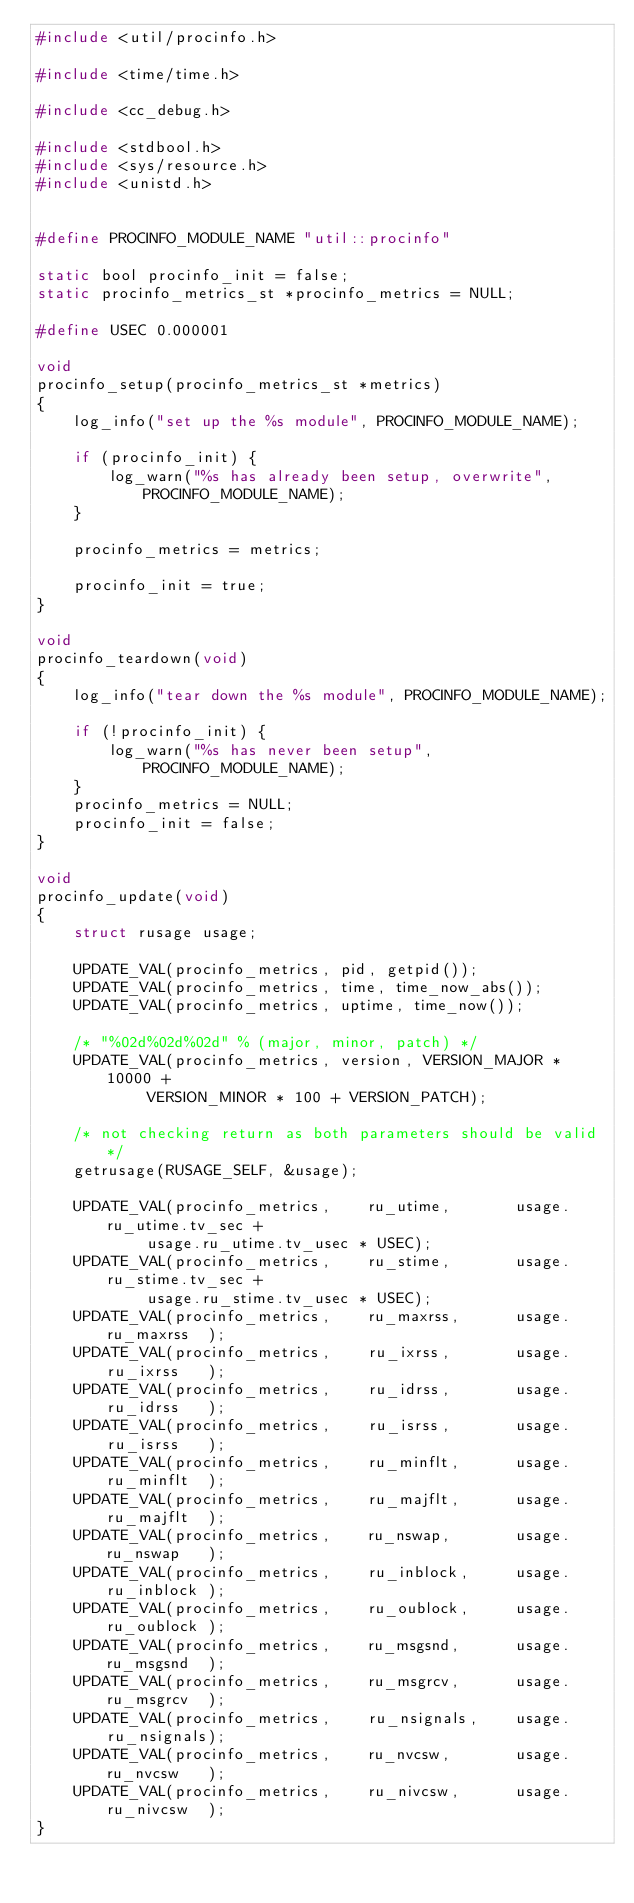<code> <loc_0><loc_0><loc_500><loc_500><_C_>#include <util/procinfo.h>

#include <time/time.h>

#include <cc_debug.h>

#include <stdbool.h>
#include <sys/resource.h>
#include <unistd.h>


#define PROCINFO_MODULE_NAME "util::procinfo"

static bool procinfo_init = false;
static procinfo_metrics_st *procinfo_metrics = NULL;

#define USEC 0.000001

void
procinfo_setup(procinfo_metrics_st *metrics)
{
    log_info("set up the %s module", PROCINFO_MODULE_NAME);

    if (procinfo_init) {
        log_warn("%s has already been setup, overwrite", PROCINFO_MODULE_NAME);
    }

    procinfo_metrics = metrics;

    procinfo_init = true;
}

void
procinfo_teardown(void)
{
    log_info("tear down the %s module", PROCINFO_MODULE_NAME);

    if (!procinfo_init) {
        log_warn("%s has never been setup", PROCINFO_MODULE_NAME);
    }
    procinfo_metrics = NULL;
    procinfo_init = false;
}

void
procinfo_update(void)
{
    struct rusage usage;

    UPDATE_VAL(procinfo_metrics, pid, getpid());
    UPDATE_VAL(procinfo_metrics, time, time_now_abs());
    UPDATE_VAL(procinfo_metrics, uptime, time_now());

    /* "%02d%02d%02d" % (major, minor, patch) */
    UPDATE_VAL(procinfo_metrics, version, VERSION_MAJOR * 10000 +
            VERSION_MINOR * 100 + VERSION_PATCH);

    /* not checking return as both parameters should be valid */
    getrusage(RUSAGE_SELF, &usage);

    UPDATE_VAL(procinfo_metrics,    ru_utime,       usage.ru_utime.tv_sec +
            usage.ru_utime.tv_usec * USEC);
    UPDATE_VAL(procinfo_metrics,    ru_stime,       usage.ru_stime.tv_sec +
            usage.ru_stime.tv_usec * USEC);
    UPDATE_VAL(procinfo_metrics,    ru_maxrss,      usage.ru_maxrss  );
    UPDATE_VAL(procinfo_metrics,    ru_ixrss,       usage.ru_ixrss   );
    UPDATE_VAL(procinfo_metrics,    ru_idrss,       usage.ru_idrss   );
    UPDATE_VAL(procinfo_metrics,    ru_isrss,       usage.ru_isrss   );
    UPDATE_VAL(procinfo_metrics,    ru_minflt,      usage.ru_minflt  );
    UPDATE_VAL(procinfo_metrics,    ru_majflt,      usage.ru_majflt  );
    UPDATE_VAL(procinfo_metrics,    ru_nswap,       usage.ru_nswap   );
    UPDATE_VAL(procinfo_metrics,    ru_inblock,     usage.ru_inblock );
    UPDATE_VAL(procinfo_metrics,    ru_oublock,     usage.ru_oublock );
    UPDATE_VAL(procinfo_metrics,    ru_msgsnd,      usage.ru_msgsnd  );
    UPDATE_VAL(procinfo_metrics,    ru_msgrcv,      usage.ru_msgrcv  );
    UPDATE_VAL(procinfo_metrics,    ru_nsignals,    usage.ru_nsignals);
    UPDATE_VAL(procinfo_metrics,    ru_nvcsw,       usage.ru_nvcsw   );
    UPDATE_VAL(procinfo_metrics,    ru_nivcsw,      usage.ru_nivcsw  );
}
</code> 